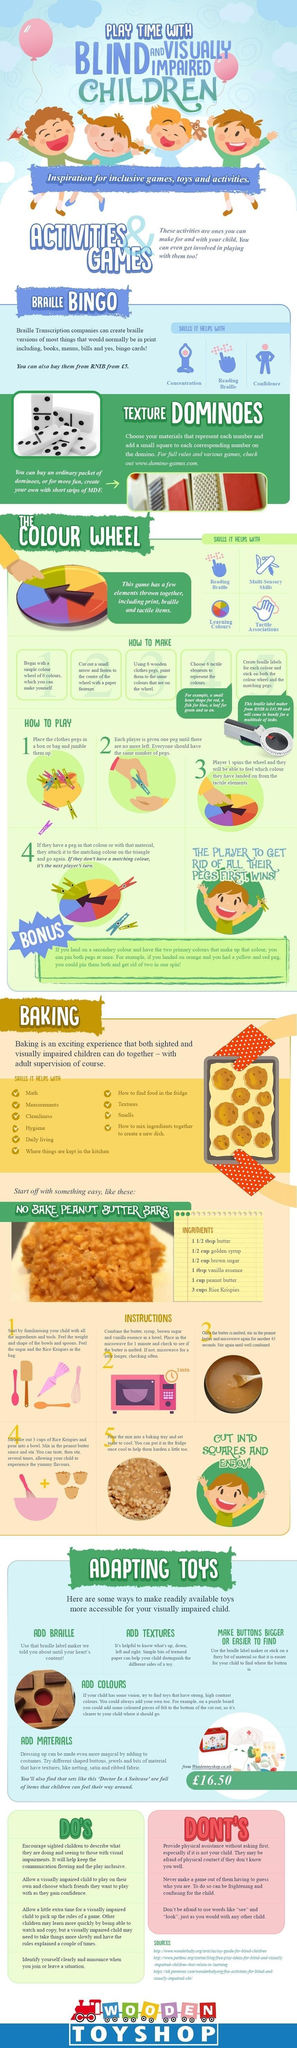What are the three benefits of Braille Bingo?
Answer the question with a short phrase. Concentration, Reading Braille, Confidence How many sources are listed? 3 